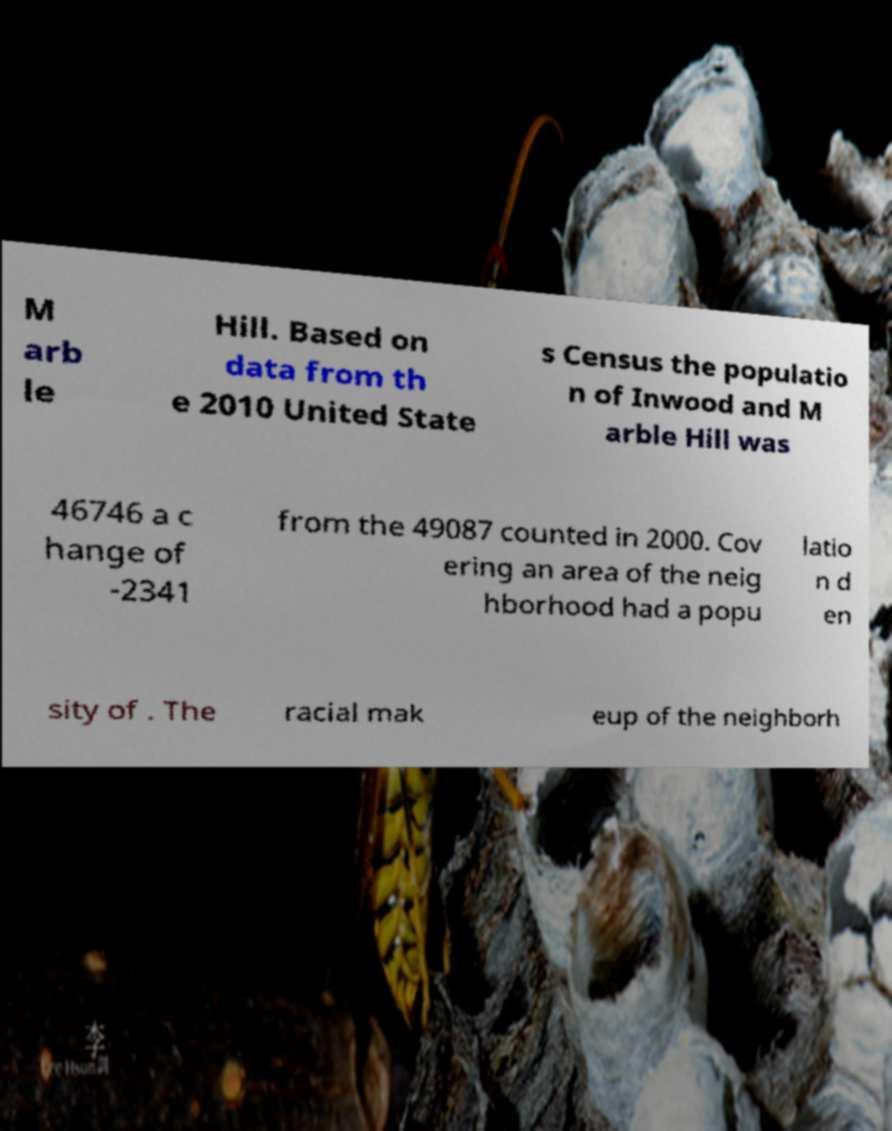What messages or text are displayed in this image? I need them in a readable, typed format. M arb le Hill. Based on data from th e 2010 United State s Census the populatio n of Inwood and M arble Hill was 46746 a c hange of -2341 from the 49087 counted in 2000. Cov ering an area of the neig hborhood had a popu latio n d en sity of . The racial mak eup of the neighborh 